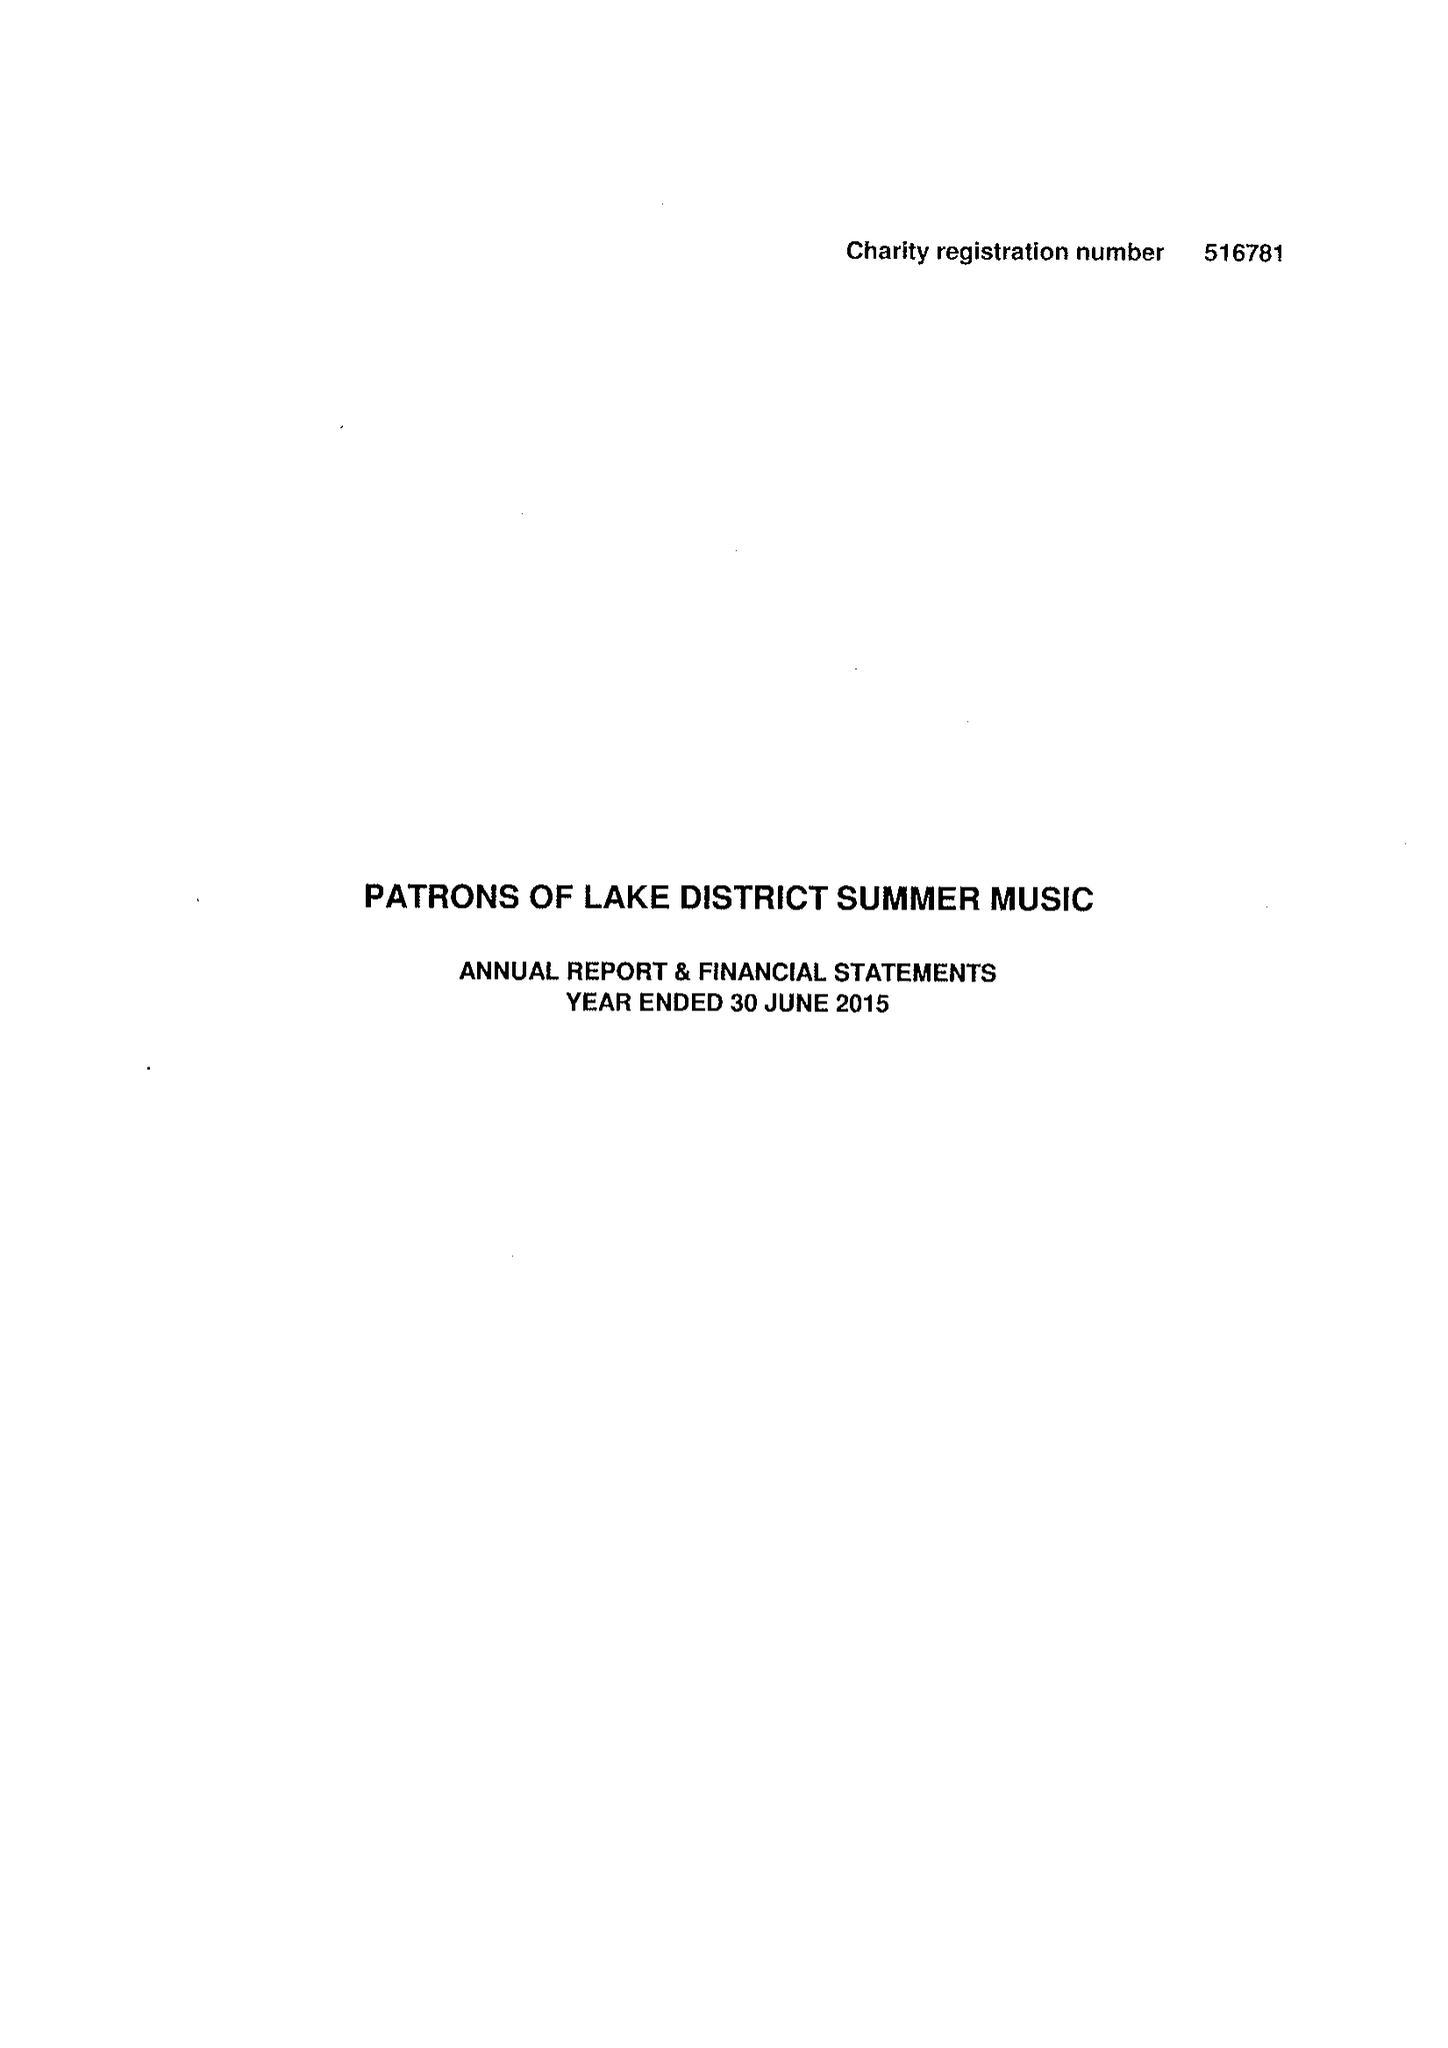What is the value for the address__postcode?
Answer the question using a single word or phrase. LA9 7NN 